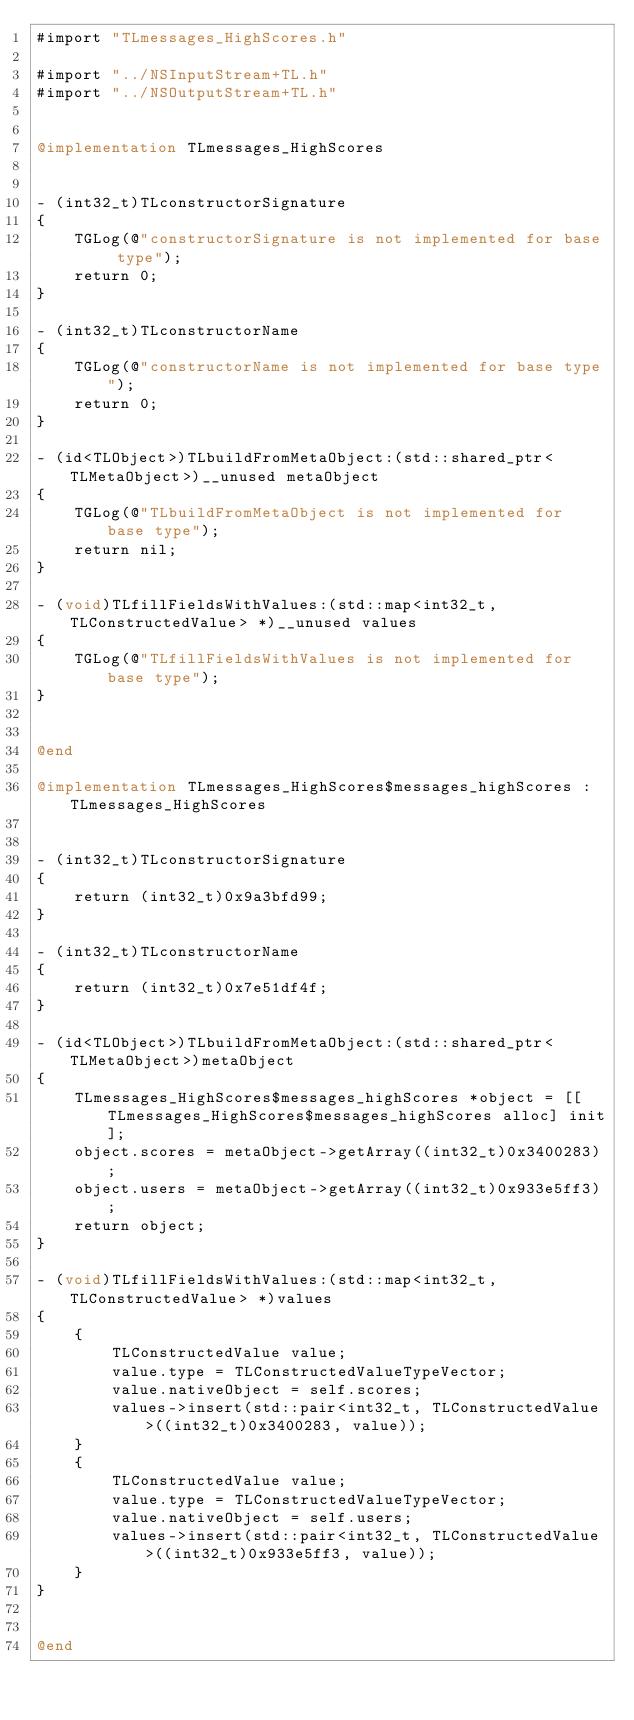<code> <loc_0><loc_0><loc_500><loc_500><_ObjectiveC_>#import "TLmessages_HighScores.h"

#import "../NSInputStream+TL.h"
#import "../NSOutputStream+TL.h"


@implementation TLmessages_HighScores


- (int32_t)TLconstructorSignature
{
    TGLog(@"constructorSignature is not implemented for base type");
    return 0;
}

- (int32_t)TLconstructorName
{
    TGLog(@"constructorName is not implemented for base type");
    return 0;
}

- (id<TLObject>)TLbuildFromMetaObject:(std::shared_ptr<TLMetaObject>)__unused metaObject
{
    TGLog(@"TLbuildFromMetaObject is not implemented for base type");
    return nil;
}

- (void)TLfillFieldsWithValues:(std::map<int32_t, TLConstructedValue> *)__unused values
{
    TGLog(@"TLfillFieldsWithValues is not implemented for base type");
}


@end

@implementation TLmessages_HighScores$messages_highScores : TLmessages_HighScores


- (int32_t)TLconstructorSignature
{
    return (int32_t)0x9a3bfd99;
}

- (int32_t)TLconstructorName
{
    return (int32_t)0x7e51df4f;
}

- (id<TLObject>)TLbuildFromMetaObject:(std::shared_ptr<TLMetaObject>)metaObject
{
    TLmessages_HighScores$messages_highScores *object = [[TLmessages_HighScores$messages_highScores alloc] init];
    object.scores = metaObject->getArray((int32_t)0x3400283);
    object.users = metaObject->getArray((int32_t)0x933e5ff3);
    return object;
}

- (void)TLfillFieldsWithValues:(std::map<int32_t, TLConstructedValue> *)values
{
    {
        TLConstructedValue value;
        value.type = TLConstructedValueTypeVector;
        value.nativeObject = self.scores;
        values->insert(std::pair<int32_t, TLConstructedValue>((int32_t)0x3400283, value));
    }
    {
        TLConstructedValue value;
        value.type = TLConstructedValueTypeVector;
        value.nativeObject = self.users;
        values->insert(std::pair<int32_t, TLConstructedValue>((int32_t)0x933e5ff3, value));
    }
}


@end

</code> 